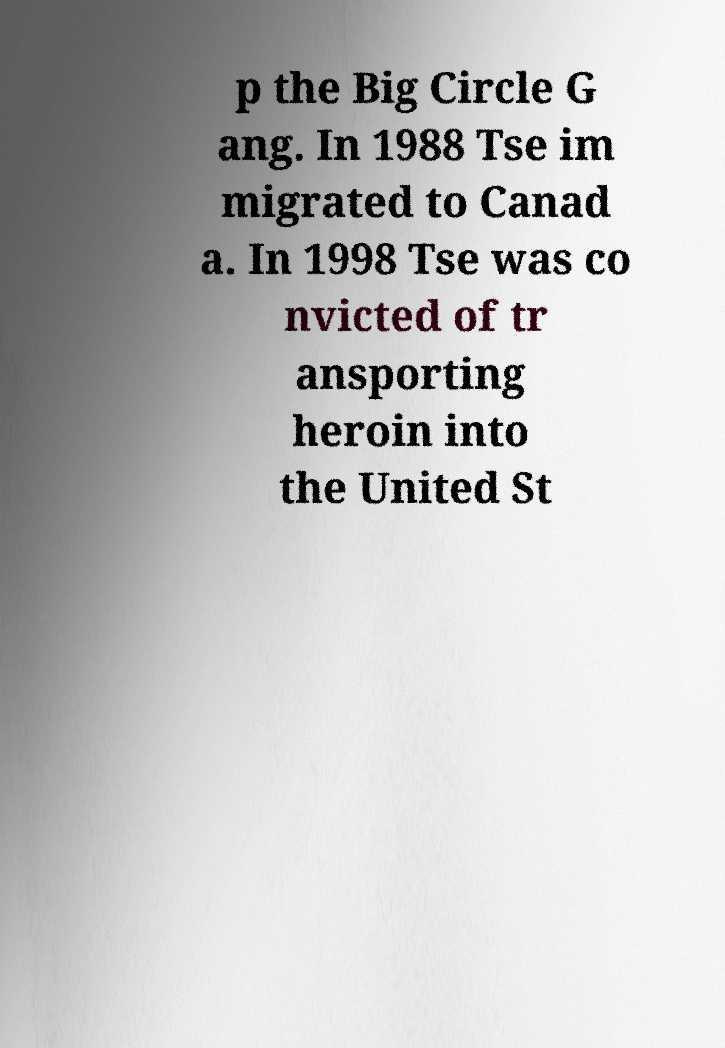There's text embedded in this image that I need extracted. Can you transcribe it verbatim? p the Big Circle G ang. In 1988 Tse im migrated to Canad a. In 1998 Tse was co nvicted of tr ansporting heroin into the United St 